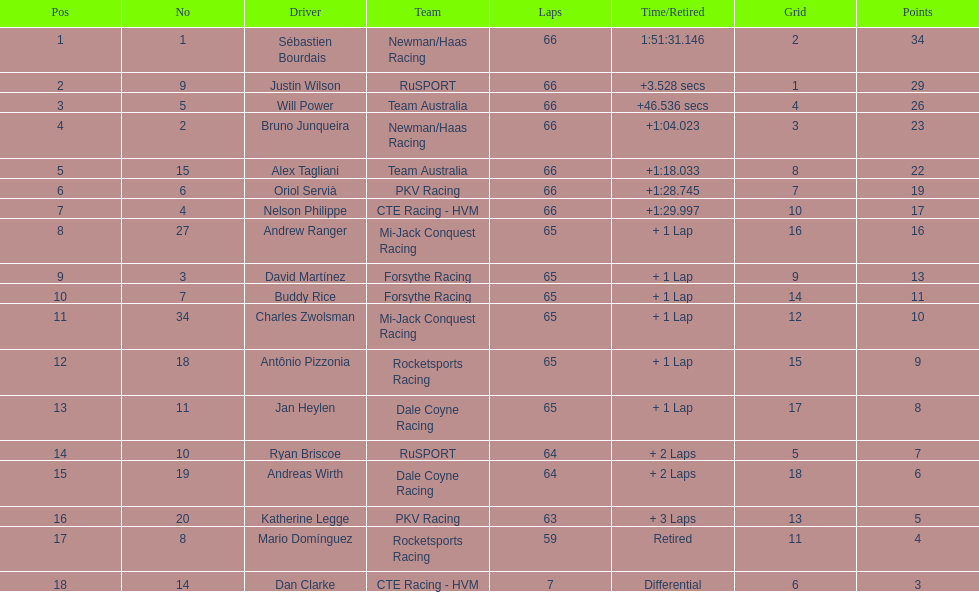How many drivers did not make more than 60 laps? 2. 